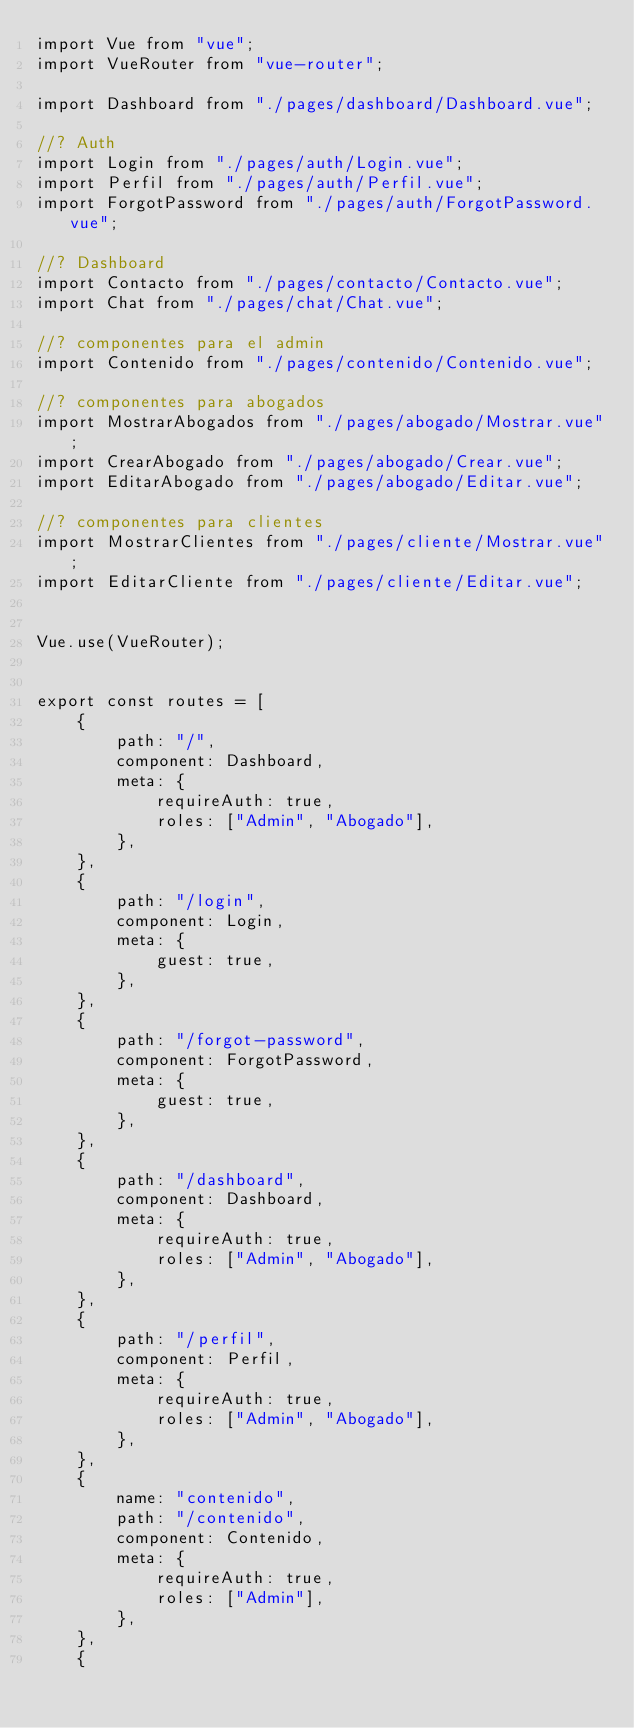Convert code to text. <code><loc_0><loc_0><loc_500><loc_500><_JavaScript_>import Vue from "vue";
import VueRouter from "vue-router";

import Dashboard from "./pages/dashboard/Dashboard.vue";

//? Auth
import Login from "./pages/auth/Login.vue";
import Perfil from "./pages/auth/Perfil.vue";
import ForgotPassword from "./pages/auth/ForgotPassword.vue";

//? Dashboard
import Contacto from "./pages/contacto/Contacto.vue";
import Chat from "./pages/chat/Chat.vue";

//? componentes para el admin
import Contenido from "./pages/contenido/Contenido.vue";

//? componentes para abogados
import MostrarAbogados from "./pages/abogado/Mostrar.vue";
import CrearAbogado from "./pages/abogado/Crear.vue";
import EditarAbogado from "./pages/abogado/Editar.vue";

//? componentes para clientes
import MostrarClientes from "./pages/cliente/Mostrar.vue";
import EditarCliente from "./pages/cliente/Editar.vue";


Vue.use(VueRouter);


export const routes = [
    {
        path: "/",
        component: Dashboard,
        meta: {
            requireAuth: true,
            roles: ["Admin", "Abogado"],
        },
    },
    {
        path: "/login",
        component: Login,
        meta: {
            guest: true,
        },
    },
    {
        path: "/forgot-password",
        component: ForgotPassword,
        meta: {
            guest: true,
        },
    },
    {
        path: "/dashboard",
        component: Dashboard,
        meta: {
            requireAuth: true,
            roles: ["Admin", "Abogado"],
        },
    },
    {
        path: "/perfil",
        component: Perfil,
        meta: {
            requireAuth: true,
            roles: ["Admin", "Abogado"],
        },
    },
    {
        name: "contenido",
        path: "/contenido",
        component: Contenido,
        meta: {
            requireAuth: true,
            roles: ["Admin"],
        },
    },
    {</code> 